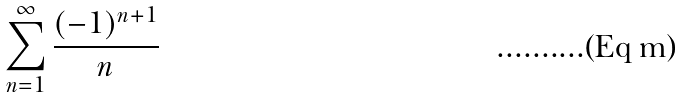Convert formula to latex. <formula><loc_0><loc_0><loc_500><loc_500>\sum _ { n = 1 } ^ { \infty } \frac { ( - 1 ) ^ { n + 1 } } { n }</formula> 